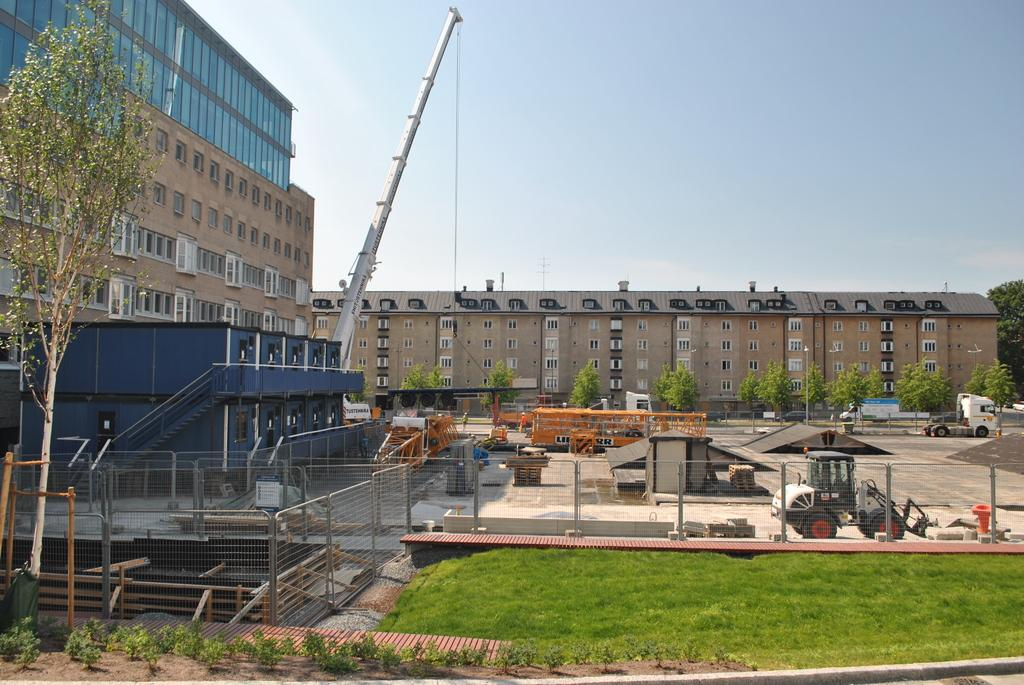What type of structure can be seen in the image? There is a fencing in the image. What type of outdoor area is visible in the image? There is a garden in the image. What type of vegetation is present in the image? There are trees in the image. What type of transportation is present in the image? There are vehicles in the image. What can be seen in the background of the image? In the background, there is a crane and buildings. What part of the natural environment is visible in the image? The sky is visible in the background. What type of pail is being used to power the crane in the image? There is no pail or indication of powering the crane in the image. How does the wind blow the trees in the image? The image does not show the wind blowing the trees; it only shows the trees in a static state. 